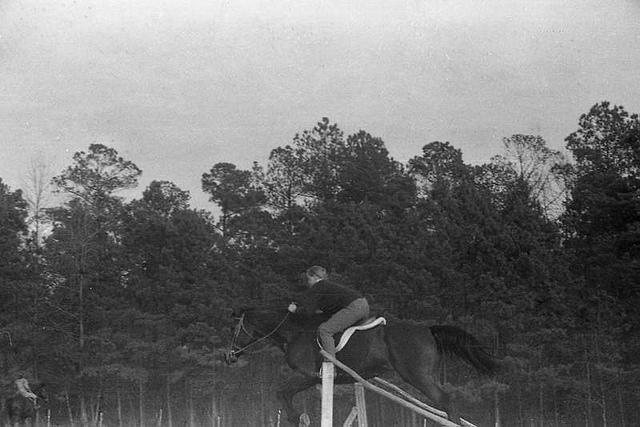Is the equestrian wearing protective gear?
Give a very brief answer. No. Is this an old photo?
Concise answer only. Yes. Is the horse jumping?
Give a very brief answer. Yes. 